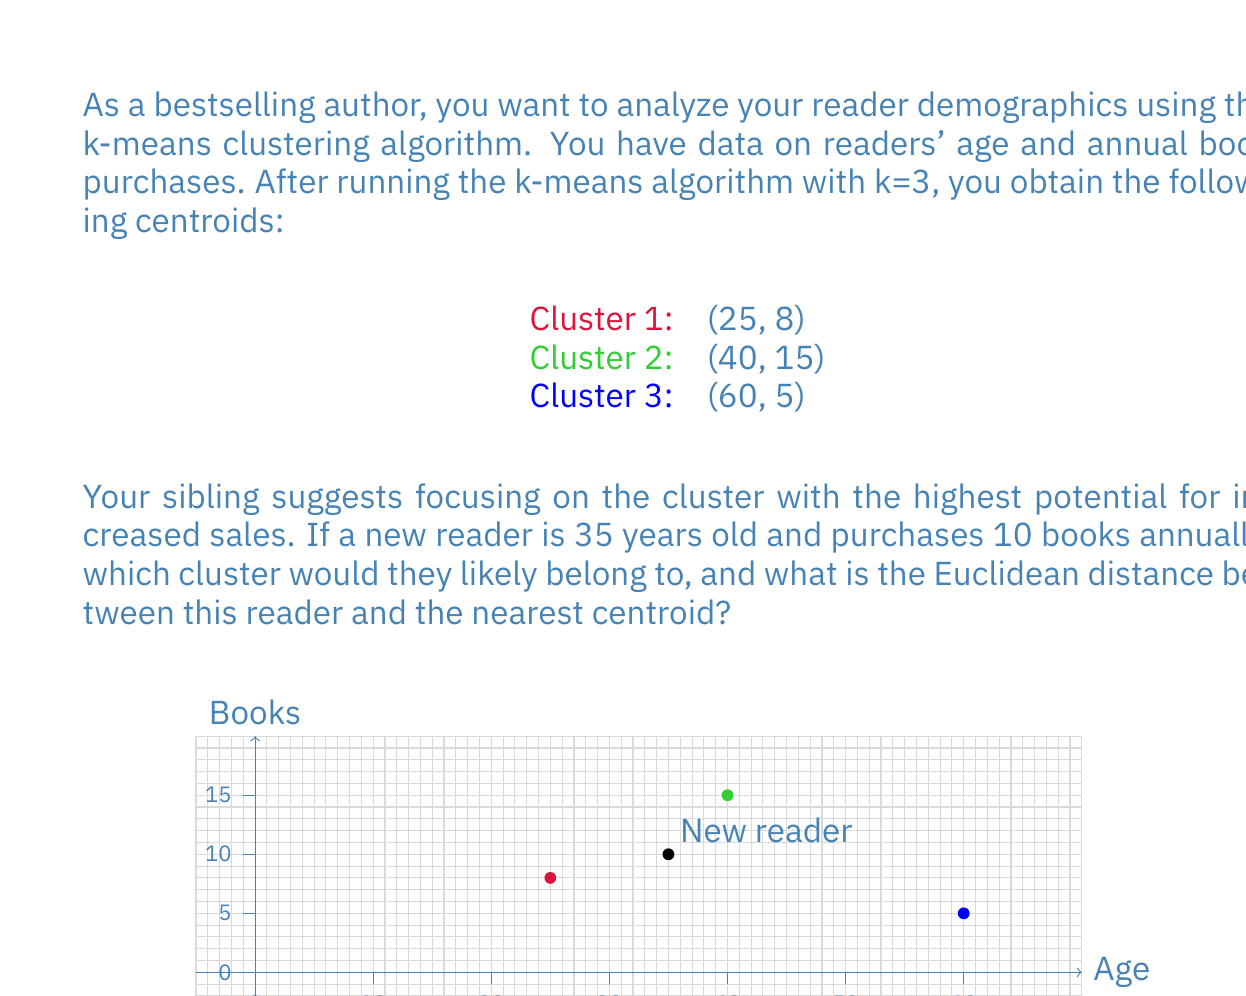Give your solution to this math problem. Let's approach this step-by-step:

1) First, we need to calculate the Euclidean distance between the new reader (35, 10) and each centroid.

2) The Euclidean distance formula in 2D space is:
   $$d = \sqrt{(x_2 - x_1)^2 + (y_2 - y_1)^2}$$

3) Let's calculate the distance to each centroid:

   For Cluster 1 (25, 8):
   $$d_1 = \sqrt{(35 - 25)^2 + (10 - 8)^2} = \sqrt{100 + 4} = \sqrt{104} \approx 10.20$$

   For Cluster 2 (40, 15):
   $$d_2 = \sqrt{(35 - 40)^2 + (10 - 15)^2} = \sqrt{25 + 25} = \sqrt{50} \approx 7.07$$

   For Cluster 3 (60, 5):
   $$d_3 = \sqrt{(35 - 60)^2 + (10 - 5)^2} = \sqrt{625 + 25} = \sqrt{650} \approx 25.50$$

4) The new reader belongs to the cluster with the nearest centroid, which is Cluster 2 with the smallest distance of approximately 7.07.
Answer: Cluster 2; 7.07 